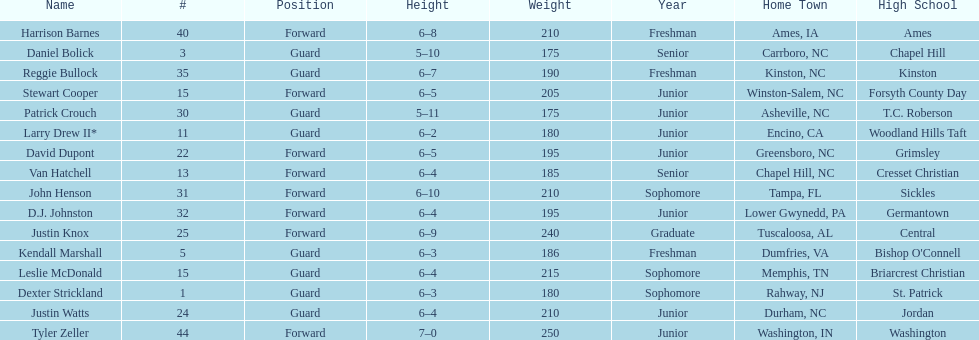What is the number of players with a weight over 200? 7. 